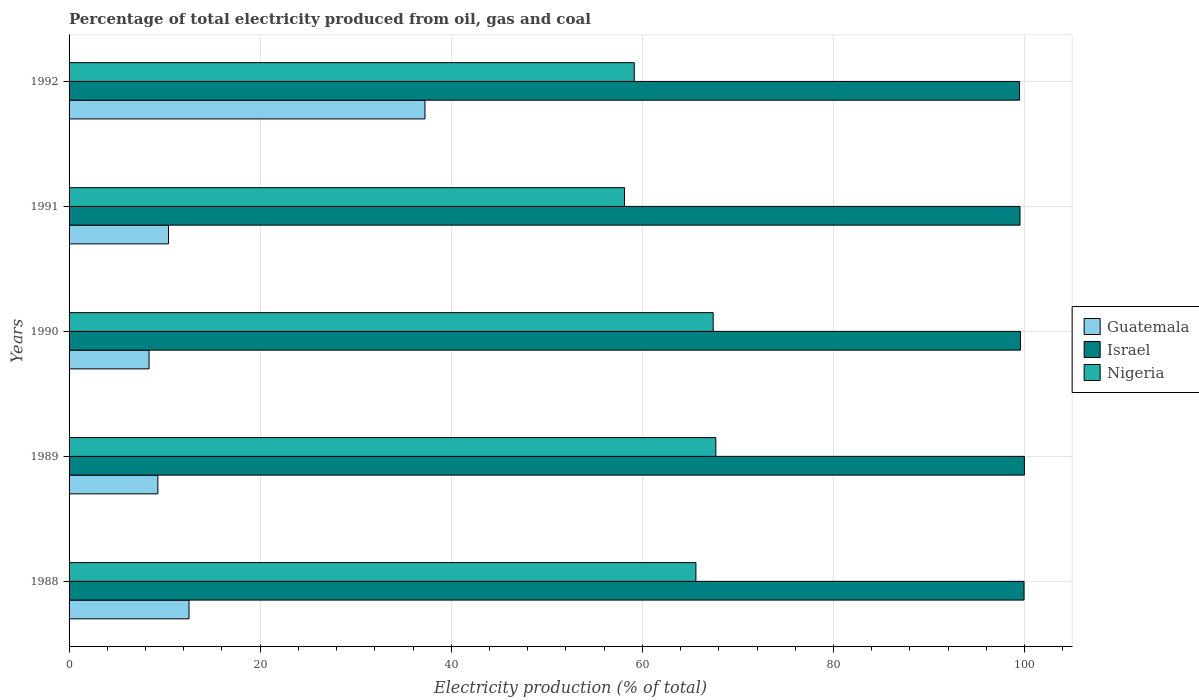How many different coloured bars are there?
Your answer should be compact. 3. How many bars are there on the 4th tick from the bottom?
Your answer should be compact. 3. In how many cases, is the number of bars for a given year not equal to the number of legend labels?
Keep it short and to the point. 0. What is the electricity production in in Israel in 1991?
Your response must be concise. 99.53. Across all years, what is the maximum electricity production in in Guatemala?
Make the answer very short. 37.25. Across all years, what is the minimum electricity production in in Guatemala?
Keep it short and to the point. 8.37. In which year was the electricity production in in Israel maximum?
Provide a short and direct response. 1989. In which year was the electricity production in in Israel minimum?
Your answer should be very brief. 1992. What is the total electricity production in in Nigeria in the graph?
Your answer should be compact. 318. What is the difference between the electricity production in in Israel in 1988 and that in 1989?
Offer a terse response. -0.04. What is the difference between the electricity production in in Guatemala in 1990 and the electricity production in in Israel in 1989?
Provide a short and direct response. -91.61. What is the average electricity production in in Nigeria per year?
Keep it short and to the point. 63.6. In the year 1989, what is the difference between the electricity production in in Israel and electricity production in in Nigeria?
Offer a terse response. 32.3. In how many years, is the electricity production in in Guatemala greater than 96 %?
Offer a terse response. 0. What is the ratio of the electricity production in in Nigeria in 1989 to that in 1991?
Ensure brevity in your answer.  1.16. Is the electricity production in in Israel in 1989 less than that in 1992?
Offer a very short reply. No. What is the difference between the highest and the second highest electricity production in in Israel?
Your answer should be compact. 0.04. What is the difference between the highest and the lowest electricity production in in Guatemala?
Provide a succinct answer. 28.88. In how many years, is the electricity production in in Guatemala greater than the average electricity production in in Guatemala taken over all years?
Your answer should be compact. 1. Is the sum of the electricity production in in Israel in 1988 and 1992 greater than the maximum electricity production in in Nigeria across all years?
Make the answer very short. Yes. What does the 3rd bar from the top in 1989 represents?
Your answer should be compact. Guatemala. What does the 1st bar from the bottom in 1990 represents?
Your response must be concise. Guatemala. Is it the case that in every year, the sum of the electricity production in in Israel and electricity production in in Guatemala is greater than the electricity production in in Nigeria?
Keep it short and to the point. Yes. Are the values on the major ticks of X-axis written in scientific E-notation?
Provide a succinct answer. No. Does the graph contain any zero values?
Your answer should be compact. No. How are the legend labels stacked?
Make the answer very short. Vertical. What is the title of the graph?
Keep it short and to the point. Percentage of total electricity produced from oil, gas and coal. Does "Croatia" appear as one of the legend labels in the graph?
Your response must be concise. No. What is the label or title of the X-axis?
Offer a terse response. Electricity production (% of total). What is the label or title of the Y-axis?
Ensure brevity in your answer.  Years. What is the Electricity production (% of total) of Guatemala in 1988?
Your response must be concise. 12.55. What is the Electricity production (% of total) in Israel in 1988?
Your response must be concise. 99.95. What is the Electricity production (% of total) of Nigeria in 1988?
Give a very brief answer. 65.61. What is the Electricity production (% of total) in Guatemala in 1989?
Your answer should be very brief. 9.29. What is the Electricity production (% of total) of Israel in 1989?
Give a very brief answer. 99.99. What is the Electricity production (% of total) of Nigeria in 1989?
Offer a terse response. 67.69. What is the Electricity production (% of total) of Guatemala in 1990?
Offer a terse response. 8.37. What is the Electricity production (% of total) of Israel in 1990?
Ensure brevity in your answer.  99.57. What is the Electricity production (% of total) in Nigeria in 1990?
Ensure brevity in your answer.  67.41. What is the Electricity production (% of total) in Guatemala in 1991?
Ensure brevity in your answer.  10.41. What is the Electricity production (% of total) in Israel in 1991?
Offer a terse response. 99.53. What is the Electricity production (% of total) of Nigeria in 1991?
Provide a short and direct response. 58.14. What is the Electricity production (% of total) in Guatemala in 1992?
Your answer should be very brief. 37.25. What is the Electricity production (% of total) of Israel in 1992?
Provide a succinct answer. 99.48. What is the Electricity production (% of total) in Nigeria in 1992?
Keep it short and to the point. 59.15. Across all years, what is the maximum Electricity production (% of total) of Guatemala?
Provide a succinct answer. 37.25. Across all years, what is the maximum Electricity production (% of total) of Israel?
Provide a short and direct response. 99.99. Across all years, what is the maximum Electricity production (% of total) of Nigeria?
Keep it short and to the point. 67.69. Across all years, what is the minimum Electricity production (% of total) of Guatemala?
Offer a very short reply. 8.37. Across all years, what is the minimum Electricity production (% of total) of Israel?
Give a very brief answer. 99.48. Across all years, what is the minimum Electricity production (% of total) in Nigeria?
Your answer should be very brief. 58.14. What is the total Electricity production (% of total) of Guatemala in the graph?
Offer a terse response. 77.88. What is the total Electricity production (% of total) in Israel in the graph?
Make the answer very short. 498.52. What is the total Electricity production (% of total) in Nigeria in the graph?
Provide a short and direct response. 318. What is the difference between the Electricity production (% of total) of Guatemala in 1988 and that in 1989?
Offer a very short reply. 3.26. What is the difference between the Electricity production (% of total) of Israel in 1988 and that in 1989?
Provide a succinct answer. -0.04. What is the difference between the Electricity production (% of total) in Nigeria in 1988 and that in 1989?
Provide a succinct answer. -2.08. What is the difference between the Electricity production (% of total) in Guatemala in 1988 and that in 1990?
Give a very brief answer. 4.18. What is the difference between the Electricity production (% of total) in Israel in 1988 and that in 1990?
Keep it short and to the point. 0.37. What is the difference between the Electricity production (% of total) of Nigeria in 1988 and that in 1990?
Your answer should be compact. -1.81. What is the difference between the Electricity production (% of total) in Guatemala in 1988 and that in 1991?
Your answer should be very brief. 2.14. What is the difference between the Electricity production (% of total) in Israel in 1988 and that in 1991?
Ensure brevity in your answer.  0.42. What is the difference between the Electricity production (% of total) in Nigeria in 1988 and that in 1991?
Your response must be concise. 7.47. What is the difference between the Electricity production (% of total) in Guatemala in 1988 and that in 1992?
Offer a very short reply. -24.69. What is the difference between the Electricity production (% of total) in Israel in 1988 and that in 1992?
Your answer should be compact. 0.47. What is the difference between the Electricity production (% of total) in Nigeria in 1988 and that in 1992?
Your answer should be compact. 6.45. What is the difference between the Electricity production (% of total) of Guatemala in 1989 and that in 1990?
Offer a very short reply. 0.92. What is the difference between the Electricity production (% of total) in Israel in 1989 and that in 1990?
Keep it short and to the point. 0.41. What is the difference between the Electricity production (% of total) in Nigeria in 1989 and that in 1990?
Offer a very short reply. 0.27. What is the difference between the Electricity production (% of total) of Guatemala in 1989 and that in 1991?
Provide a short and direct response. -1.12. What is the difference between the Electricity production (% of total) in Israel in 1989 and that in 1991?
Your response must be concise. 0.46. What is the difference between the Electricity production (% of total) in Nigeria in 1989 and that in 1991?
Make the answer very short. 9.55. What is the difference between the Electricity production (% of total) of Guatemala in 1989 and that in 1992?
Keep it short and to the point. -27.95. What is the difference between the Electricity production (% of total) of Israel in 1989 and that in 1992?
Give a very brief answer. 0.5. What is the difference between the Electricity production (% of total) in Nigeria in 1989 and that in 1992?
Offer a very short reply. 8.53. What is the difference between the Electricity production (% of total) in Guatemala in 1990 and that in 1991?
Make the answer very short. -2.04. What is the difference between the Electricity production (% of total) in Israel in 1990 and that in 1991?
Make the answer very short. 0.05. What is the difference between the Electricity production (% of total) of Nigeria in 1990 and that in 1991?
Your answer should be very brief. 9.28. What is the difference between the Electricity production (% of total) in Guatemala in 1990 and that in 1992?
Make the answer very short. -28.88. What is the difference between the Electricity production (% of total) in Israel in 1990 and that in 1992?
Offer a very short reply. 0.09. What is the difference between the Electricity production (% of total) in Nigeria in 1990 and that in 1992?
Ensure brevity in your answer.  8.26. What is the difference between the Electricity production (% of total) in Guatemala in 1991 and that in 1992?
Your answer should be very brief. -26.84. What is the difference between the Electricity production (% of total) in Israel in 1991 and that in 1992?
Keep it short and to the point. 0.04. What is the difference between the Electricity production (% of total) in Nigeria in 1991 and that in 1992?
Make the answer very short. -1.02. What is the difference between the Electricity production (% of total) of Guatemala in 1988 and the Electricity production (% of total) of Israel in 1989?
Your answer should be very brief. -87.43. What is the difference between the Electricity production (% of total) of Guatemala in 1988 and the Electricity production (% of total) of Nigeria in 1989?
Give a very brief answer. -55.13. What is the difference between the Electricity production (% of total) in Israel in 1988 and the Electricity production (% of total) in Nigeria in 1989?
Provide a short and direct response. 32.26. What is the difference between the Electricity production (% of total) of Guatemala in 1988 and the Electricity production (% of total) of Israel in 1990?
Your answer should be very brief. -87.02. What is the difference between the Electricity production (% of total) of Guatemala in 1988 and the Electricity production (% of total) of Nigeria in 1990?
Offer a very short reply. -54.86. What is the difference between the Electricity production (% of total) of Israel in 1988 and the Electricity production (% of total) of Nigeria in 1990?
Provide a short and direct response. 32.53. What is the difference between the Electricity production (% of total) of Guatemala in 1988 and the Electricity production (% of total) of Israel in 1991?
Make the answer very short. -86.97. What is the difference between the Electricity production (% of total) of Guatemala in 1988 and the Electricity production (% of total) of Nigeria in 1991?
Ensure brevity in your answer.  -45.58. What is the difference between the Electricity production (% of total) in Israel in 1988 and the Electricity production (% of total) in Nigeria in 1991?
Provide a succinct answer. 41.81. What is the difference between the Electricity production (% of total) of Guatemala in 1988 and the Electricity production (% of total) of Israel in 1992?
Provide a short and direct response. -86.93. What is the difference between the Electricity production (% of total) of Guatemala in 1988 and the Electricity production (% of total) of Nigeria in 1992?
Provide a succinct answer. -46.6. What is the difference between the Electricity production (% of total) of Israel in 1988 and the Electricity production (% of total) of Nigeria in 1992?
Give a very brief answer. 40.79. What is the difference between the Electricity production (% of total) in Guatemala in 1989 and the Electricity production (% of total) in Israel in 1990?
Ensure brevity in your answer.  -90.28. What is the difference between the Electricity production (% of total) in Guatemala in 1989 and the Electricity production (% of total) in Nigeria in 1990?
Keep it short and to the point. -58.12. What is the difference between the Electricity production (% of total) in Israel in 1989 and the Electricity production (% of total) in Nigeria in 1990?
Provide a succinct answer. 32.57. What is the difference between the Electricity production (% of total) in Guatemala in 1989 and the Electricity production (% of total) in Israel in 1991?
Offer a terse response. -90.23. What is the difference between the Electricity production (% of total) in Guatemala in 1989 and the Electricity production (% of total) in Nigeria in 1991?
Give a very brief answer. -48.84. What is the difference between the Electricity production (% of total) of Israel in 1989 and the Electricity production (% of total) of Nigeria in 1991?
Your answer should be very brief. 41.85. What is the difference between the Electricity production (% of total) in Guatemala in 1989 and the Electricity production (% of total) in Israel in 1992?
Keep it short and to the point. -90.19. What is the difference between the Electricity production (% of total) of Guatemala in 1989 and the Electricity production (% of total) of Nigeria in 1992?
Offer a terse response. -49.86. What is the difference between the Electricity production (% of total) in Israel in 1989 and the Electricity production (% of total) in Nigeria in 1992?
Offer a very short reply. 40.83. What is the difference between the Electricity production (% of total) in Guatemala in 1990 and the Electricity production (% of total) in Israel in 1991?
Provide a short and direct response. -91.15. What is the difference between the Electricity production (% of total) in Guatemala in 1990 and the Electricity production (% of total) in Nigeria in 1991?
Offer a terse response. -49.76. What is the difference between the Electricity production (% of total) of Israel in 1990 and the Electricity production (% of total) of Nigeria in 1991?
Provide a short and direct response. 41.44. What is the difference between the Electricity production (% of total) of Guatemala in 1990 and the Electricity production (% of total) of Israel in 1992?
Offer a very short reply. -91.11. What is the difference between the Electricity production (% of total) of Guatemala in 1990 and the Electricity production (% of total) of Nigeria in 1992?
Your answer should be very brief. -50.78. What is the difference between the Electricity production (% of total) of Israel in 1990 and the Electricity production (% of total) of Nigeria in 1992?
Make the answer very short. 40.42. What is the difference between the Electricity production (% of total) of Guatemala in 1991 and the Electricity production (% of total) of Israel in 1992?
Provide a succinct answer. -89.07. What is the difference between the Electricity production (% of total) of Guatemala in 1991 and the Electricity production (% of total) of Nigeria in 1992?
Your answer should be compact. -48.74. What is the difference between the Electricity production (% of total) in Israel in 1991 and the Electricity production (% of total) in Nigeria in 1992?
Your answer should be compact. 40.37. What is the average Electricity production (% of total) in Guatemala per year?
Provide a succinct answer. 15.58. What is the average Electricity production (% of total) in Israel per year?
Offer a very short reply. 99.7. What is the average Electricity production (% of total) in Nigeria per year?
Your answer should be compact. 63.6. In the year 1988, what is the difference between the Electricity production (% of total) in Guatemala and Electricity production (% of total) in Israel?
Provide a short and direct response. -87.39. In the year 1988, what is the difference between the Electricity production (% of total) of Guatemala and Electricity production (% of total) of Nigeria?
Keep it short and to the point. -53.05. In the year 1988, what is the difference between the Electricity production (% of total) of Israel and Electricity production (% of total) of Nigeria?
Ensure brevity in your answer.  34.34. In the year 1989, what is the difference between the Electricity production (% of total) of Guatemala and Electricity production (% of total) of Israel?
Offer a very short reply. -90.69. In the year 1989, what is the difference between the Electricity production (% of total) in Guatemala and Electricity production (% of total) in Nigeria?
Ensure brevity in your answer.  -58.39. In the year 1989, what is the difference between the Electricity production (% of total) of Israel and Electricity production (% of total) of Nigeria?
Your response must be concise. 32.3. In the year 1990, what is the difference between the Electricity production (% of total) of Guatemala and Electricity production (% of total) of Israel?
Provide a short and direct response. -91.2. In the year 1990, what is the difference between the Electricity production (% of total) in Guatemala and Electricity production (% of total) in Nigeria?
Give a very brief answer. -59.04. In the year 1990, what is the difference between the Electricity production (% of total) in Israel and Electricity production (% of total) in Nigeria?
Offer a very short reply. 32.16. In the year 1991, what is the difference between the Electricity production (% of total) of Guatemala and Electricity production (% of total) of Israel?
Your answer should be very brief. -89.11. In the year 1991, what is the difference between the Electricity production (% of total) in Guatemala and Electricity production (% of total) in Nigeria?
Offer a terse response. -47.72. In the year 1991, what is the difference between the Electricity production (% of total) in Israel and Electricity production (% of total) in Nigeria?
Keep it short and to the point. 41.39. In the year 1992, what is the difference between the Electricity production (% of total) of Guatemala and Electricity production (% of total) of Israel?
Provide a succinct answer. -62.23. In the year 1992, what is the difference between the Electricity production (% of total) of Guatemala and Electricity production (% of total) of Nigeria?
Make the answer very short. -21.91. In the year 1992, what is the difference between the Electricity production (% of total) in Israel and Electricity production (% of total) in Nigeria?
Your response must be concise. 40.33. What is the ratio of the Electricity production (% of total) of Guatemala in 1988 to that in 1989?
Your answer should be very brief. 1.35. What is the ratio of the Electricity production (% of total) of Nigeria in 1988 to that in 1989?
Provide a short and direct response. 0.97. What is the ratio of the Electricity production (% of total) in Guatemala in 1988 to that in 1990?
Make the answer very short. 1.5. What is the ratio of the Electricity production (% of total) of Israel in 1988 to that in 1990?
Keep it short and to the point. 1. What is the ratio of the Electricity production (% of total) in Nigeria in 1988 to that in 1990?
Provide a short and direct response. 0.97. What is the ratio of the Electricity production (% of total) of Guatemala in 1988 to that in 1991?
Your response must be concise. 1.21. What is the ratio of the Electricity production (% of total) of Israel in 1988 to that in 1991?
Your answer should be very brief. 1. What is the ratio of the Electricity production (% of total) of Nigeria in 1988 to that in 1991?
Give a very brief answer. 1.13. What is the ratio of the Electricity production (% of total) of Guatemala in 1988 to that in 1992?
Provide a short and direct response. 0.34. What is the ratio of the Electricity production (% of total) in Nigeria in 1988 to that in 1992?
Provide a short and direct response. 1.11. What is the ratio of the Electricity production (% of total) of Guatemala in 1989 to that in 1990?
Offer a very short reply. 1.11. What is the ratio of the Electricity production (% of total) of Israel in 1989 to that in 1990?
Keep it short and to the point. 1. What is the ratio of the Electricity production (% of total) of Nigeria in 1989 to that in 1990?
Provide a short and direct response. 1. What is the ratio of the Electricity production (% of total) in Guatemala in 1989 to that in 1991?
Provide a short and direct response. 0.89. What is the ratio of the Electricity production (% of total) of Israel in 1989 to that in 1991?
Provide a short and direct response. 1. What is the ratio of the Electricity production (% of total) of Nigeria in 1989 to that in 1991?
Your answer should be very brief. 1.16. What is the ratio of the Electricity production (% of total) in Guatemala in 1989 to that in 1992?
Give a very brief answer. 0.25. What is the ratio of the Electricity production (% of total) in Israel in 1989 to that in 1992?
Your response must be concise. 1. What is the ratio of the Electricity production (% of total) of Nigeria in 1989 to that in 1992?
Your answer should be compact. 1.14. What is the ratio of the Electricity production (% of total) in Guatemala in 1990 to that in 1991?
Ensure brevity in your answer.  0.8. What is the ratio of the Electricity production (% of total) of Israel in 1990 to that in 1991?
Your response must be concise. 1. What is the ratio of the Electricity production (% of total) in Nigeria in 1990 to that in 1991?
Offer a very short reply. 1.16. What is the ratio of the Electricity production (% of total) of Guatemala in 1990 to that in 1992?
Offer a very short reply. 0.22. What is the ratio of the Electricity production (% of total) in Nigeria in 1990 to that in 1992?
Offer a terse response. 1.14. What is the ratio of the Electricity production (% of total) of Guatemala in 1991 to that in 1992?
Make the answer very short. 0.28. What is the ratio of the Electricity production (% of total) in Israel in 1991 to that in 1992?
Offer a very short reply. 1. What is the ratio of the Electricity production (% of total) in Nigeria in 1991 to that in 1992?
Provide a short and direct response. 0.98. What is the difference between the highest and the second highest Electricity production (% of total) in Guatemala?
Your response must be concise. 24.69. What is the difference between the highest and the second highest Electricity production (% of total) of Israel?
Your answer should be very brief. 0.04. What is the difference between the highest and the second highest Electricity production (% of total) of Nigeria?
Give a very brief answer. 0.27. What is the difference between the highest and the lowest Electricity production (% of total) of Guatemala?
Provide a short and direct response. 28.88. What is the difference between the highest and the lowest Electricity production (% of total) in Israel?
Provide a succinct answer. 0.5. What is the difference between the highest and the lowest Electricity production (% of total) in Nigeria?
Your answer should be very brief. 9.55. 